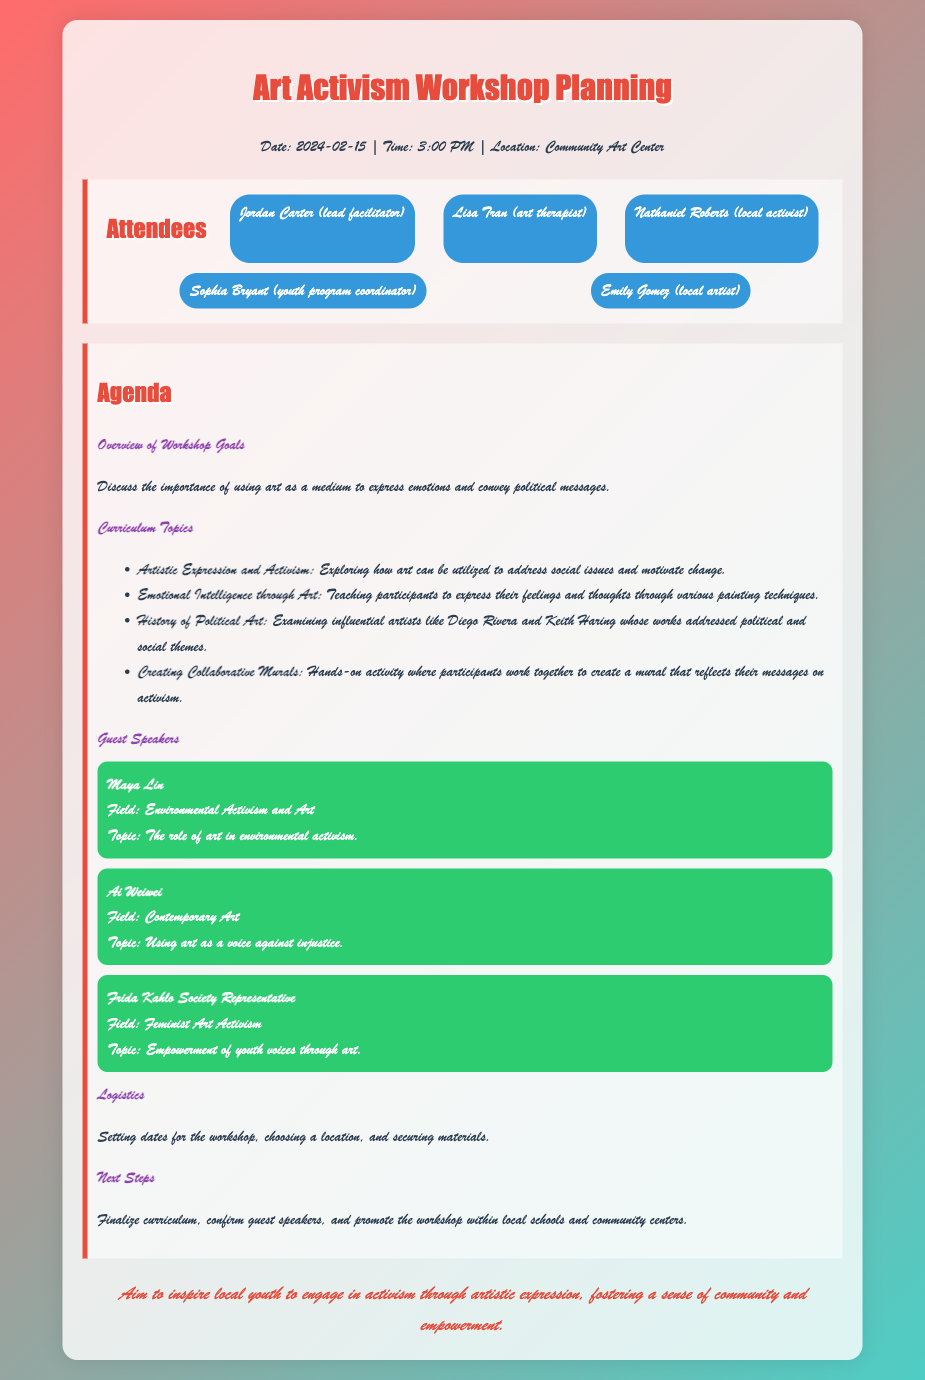What is the date of the workshop? The document specifies the date of the workshop as February 15, 2024.
Answer: February 15, 2024 Who is the lead facilitator of the workshop? The document lists Jordan Carter as the lead facilitator of the workshop.
Answer: Jordan Carter What is one of the curriculum topics related to emotional expression? The document mentions "Emotional Intelligence through Art" as a topic that teaches participants to express their feelings.
Answer: Emotional Intelligence through Art Which guest speaker focuses on environmental activism? The document identifies Maya Lin as the guest speaker focusing on environmental activism and art.
Answer: Maya Lin What logistical aspect is mentioned in the agenda? The agenda discusses setting dates for the workshop, choosing a location, and securing materials as logistical aspects.
Answer: Setting dates What hands-on activity is included in the curriculum? The document describes "Creating Collaborative Murals" as a hands-on activity for participants to work together on a mural.
Answer: Creating Collaborative Murals How many guest speakers are listed in the document? The document lists three guest speakers involved in the workshop.
Answer: Three What is the aim of the workshop mentioned in the conclusion? The conclusion states the aim is to inspire local youth to engage in activism through artistic expression.
Answer: Inspire local youth What does the document label as the next steps following the meeting? The document indicates that the next steps include finalizing the curriculum and confirming guest speakers.
Answer: Finalize curriculum 